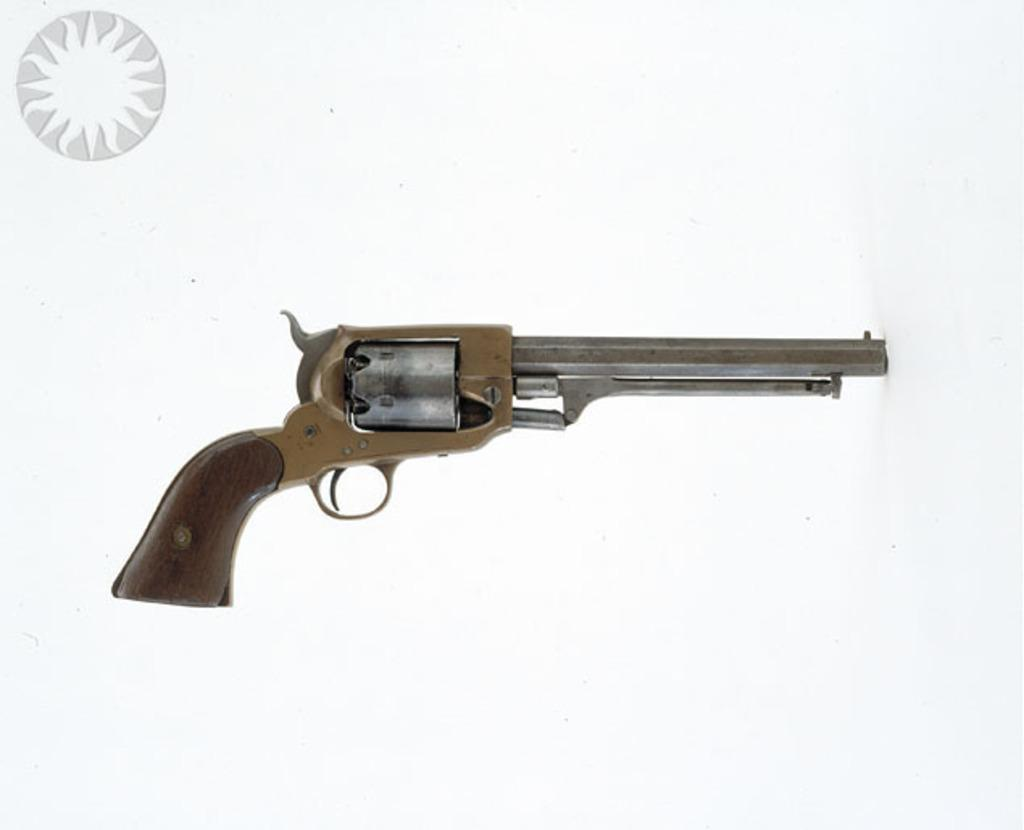What object is the main focus of the image? There is a gun in the image. Is there any text or symbol in the image? Yes, there is a logo in the top left corner of the image. What color is the background of the image? The background of the image is white. What type of cheese is being grated in the image? There is no cheese or grating activity present in the image. Can you see any bubbles floating in the image? There are no bubbles visible in the image. 